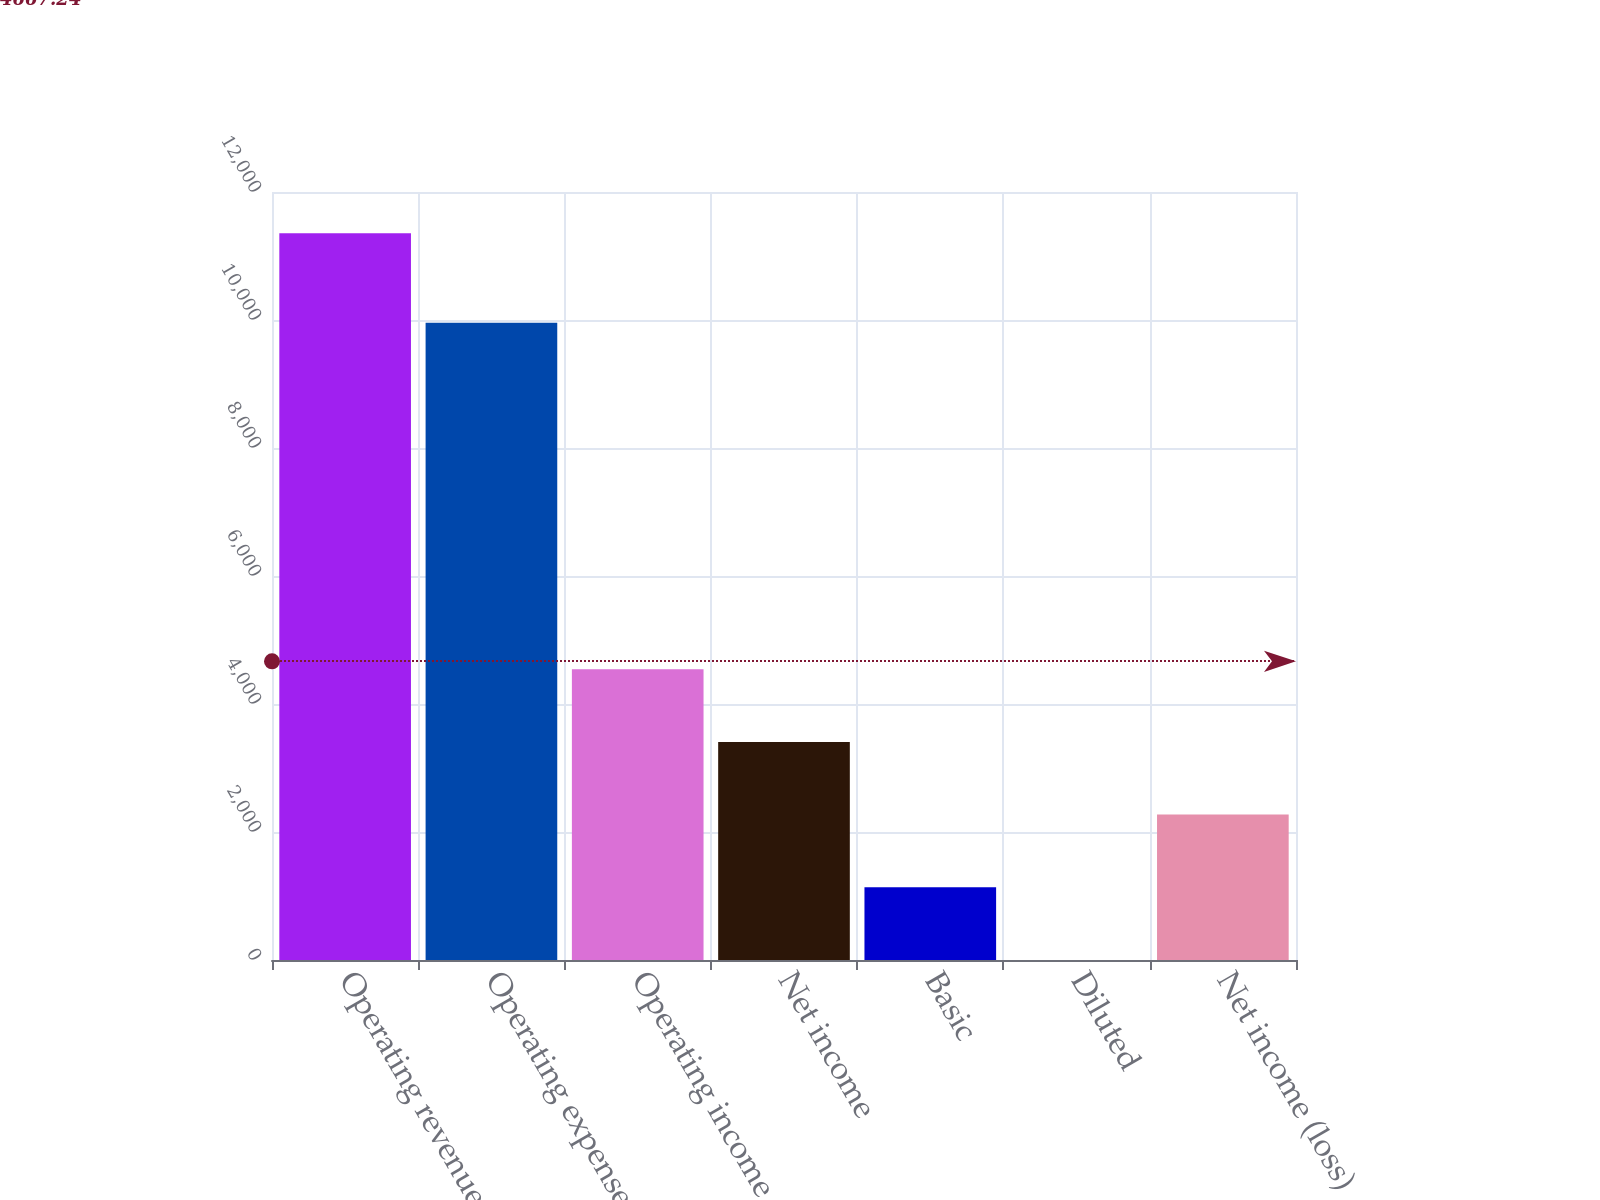Convert chart. <chart><loc_0><loc_0><loc_500><loc_500><bar_chart><fcel>Operating revenues<fcel>Operating expenses<fcel>Operating income<fcel>Net income<fcel>Basic<fcel>Diluted<fcel>Net income (loss)<nl><fcel>11355<fcel>9956<fcel>4542.69<fcel>3407.31<fcel>1136.55<fcel>1.17<fcel>2271.93<nl></chart> 